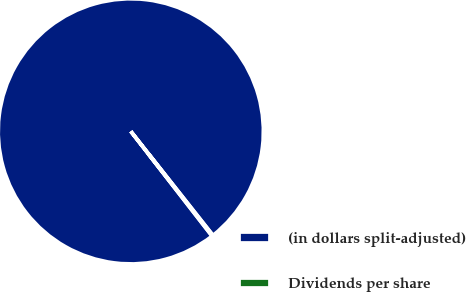<chart> <loc_0><loc_0><loc_500><loc_500><pie_chart><fcel>(in dollars split-adjusted)<fcel>Dividends per share<nl><fcel>99.86%<fcel>0.14%<nl></chart> 